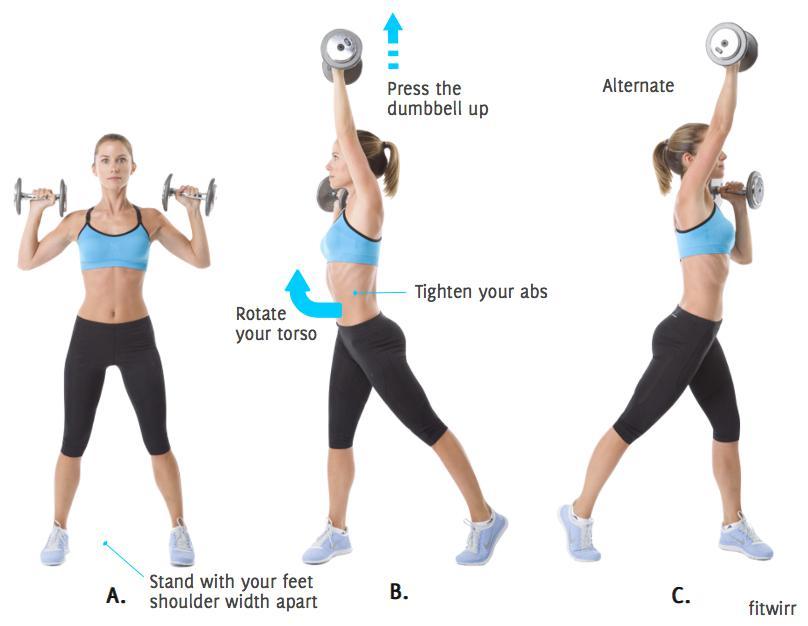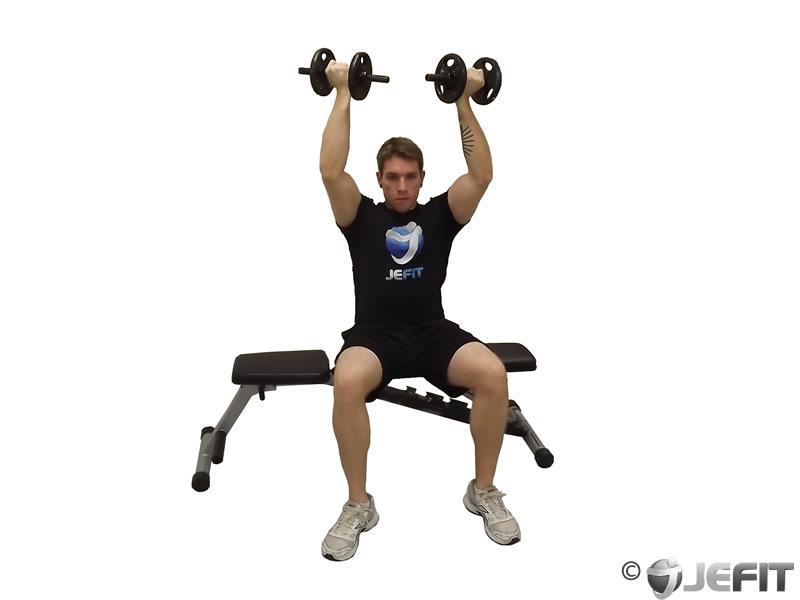The first image is the image on the left, the second image is the image on the right. Given the left and right images, does the statement "One image shows a woman doing weightlifting exercises" hold true? Answer yes or no. Yes. 